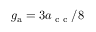<formula> <loc_0><loc_0><loc_500><loc_500>g _ { a } = 3 a _ { c c } / 8</formula> 